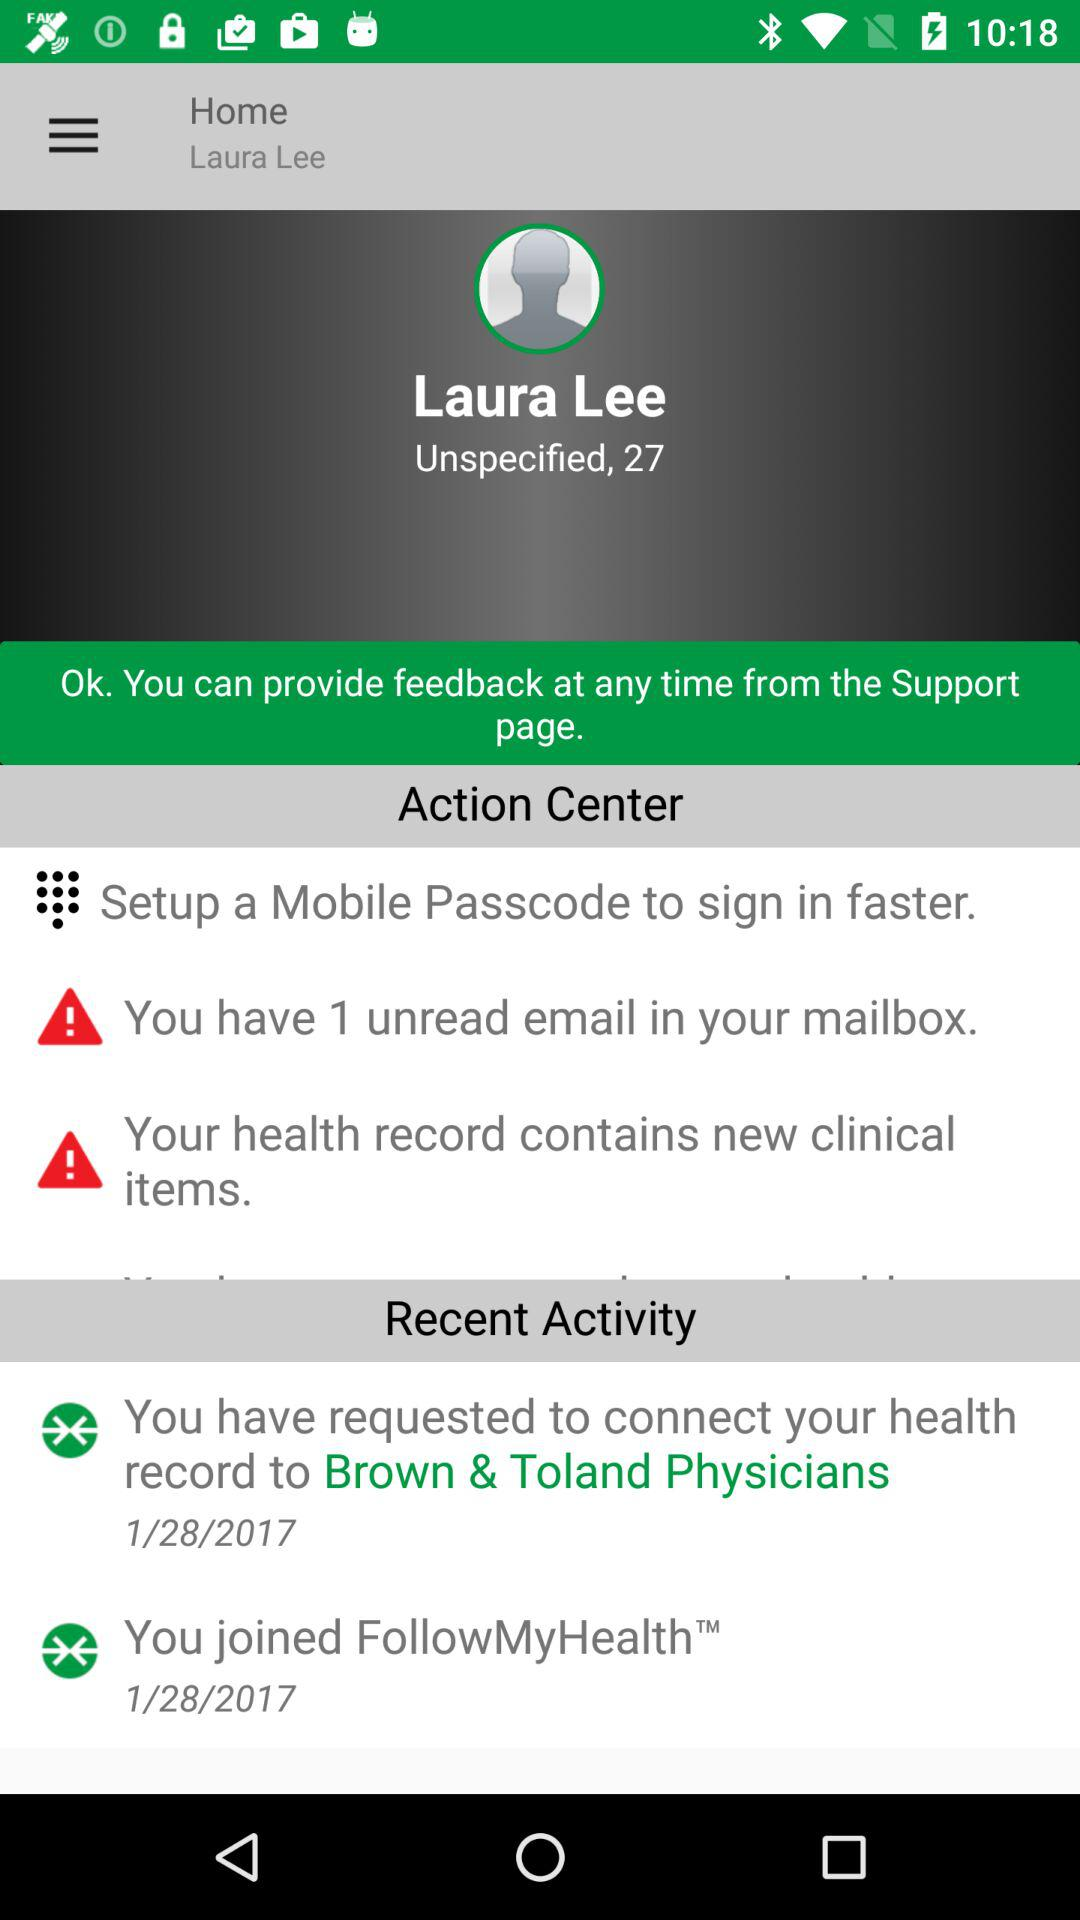What is the given profile name? The given profile name is Laura Lee. 